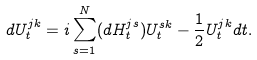<formula> <loc_0><loc_0><loc_500><loc_500>d { U _ { t } ^ { j k } } = i \sum _ { s = 1 } ^ { N } ( d { H _ { t } ^ { j s } } ) U _ { t } ^ { s k } - \frac { 1 } { 2 } U _ { t } ^ { j k } d { t } .</formula> 